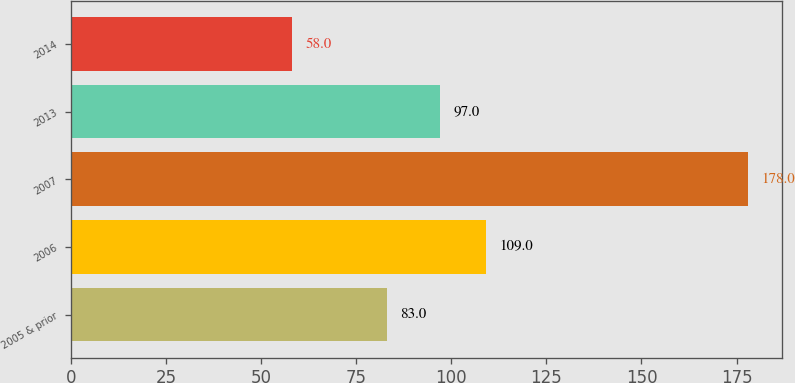Convert chart. <chart><loc_0><loc_0><loc_500><loc_500><bar_chart><fcel>2005 & prior<fcel>2006<fcel>2007<fcel>2013<fcel>2014<nl><fcel>83<fcel>109<fcel>178<fcel>97<fcel>58<nl></chart> 